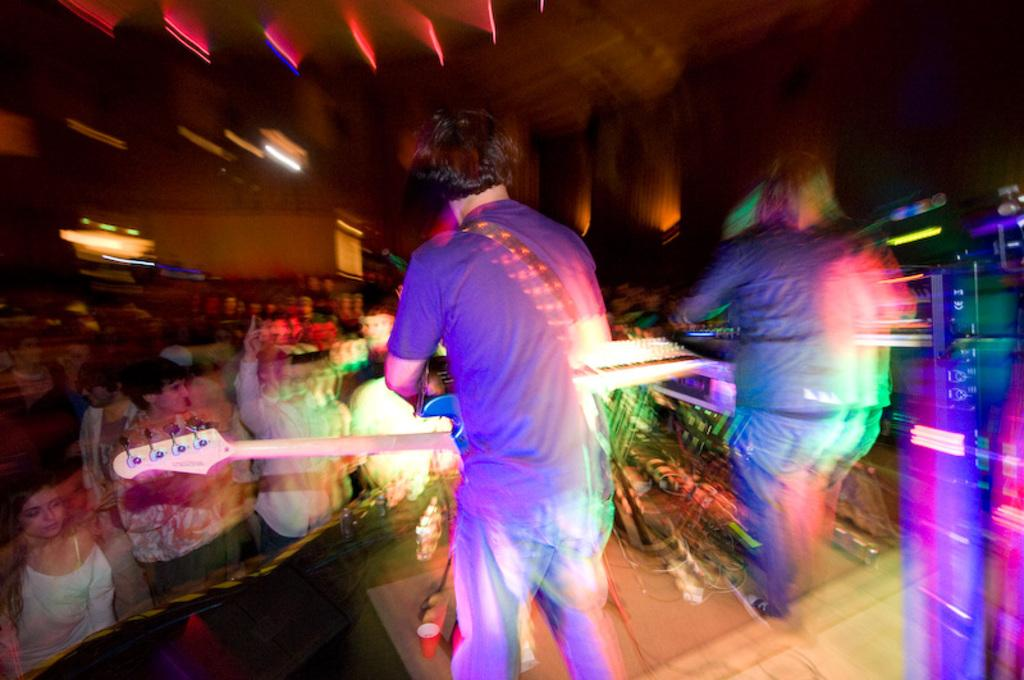How many people are on the stage in the image? There are two persons standing on the stage in the image. What are the two persons on the stage holding? The two persons on the stage are holding a guitar. Can you describe the people in the background of the image? There are other persons standing in the background of the image. What is the location of the wall in the image? There is a wall at the top of the image. What type of stamp can be seen on the guitar in the image? There is no stamp visible on the guitar in the image. 